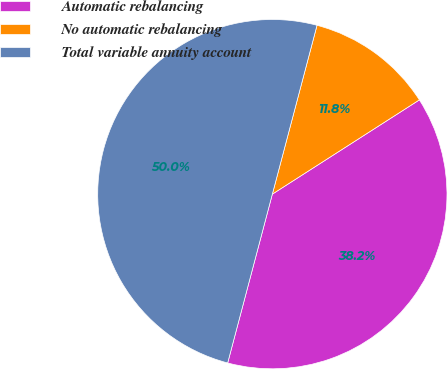Convert chart to OTSL. <chart><loc_0><loc_0><loc_500><loc_500><pie_chart><fcel>Automatic rebalancing<fcel>No automatic rebalancing<fcel>Total variable annuity account<nl><fcel>38.19%<fcel>11.81%<fcel>50.0%<nl></chart> 